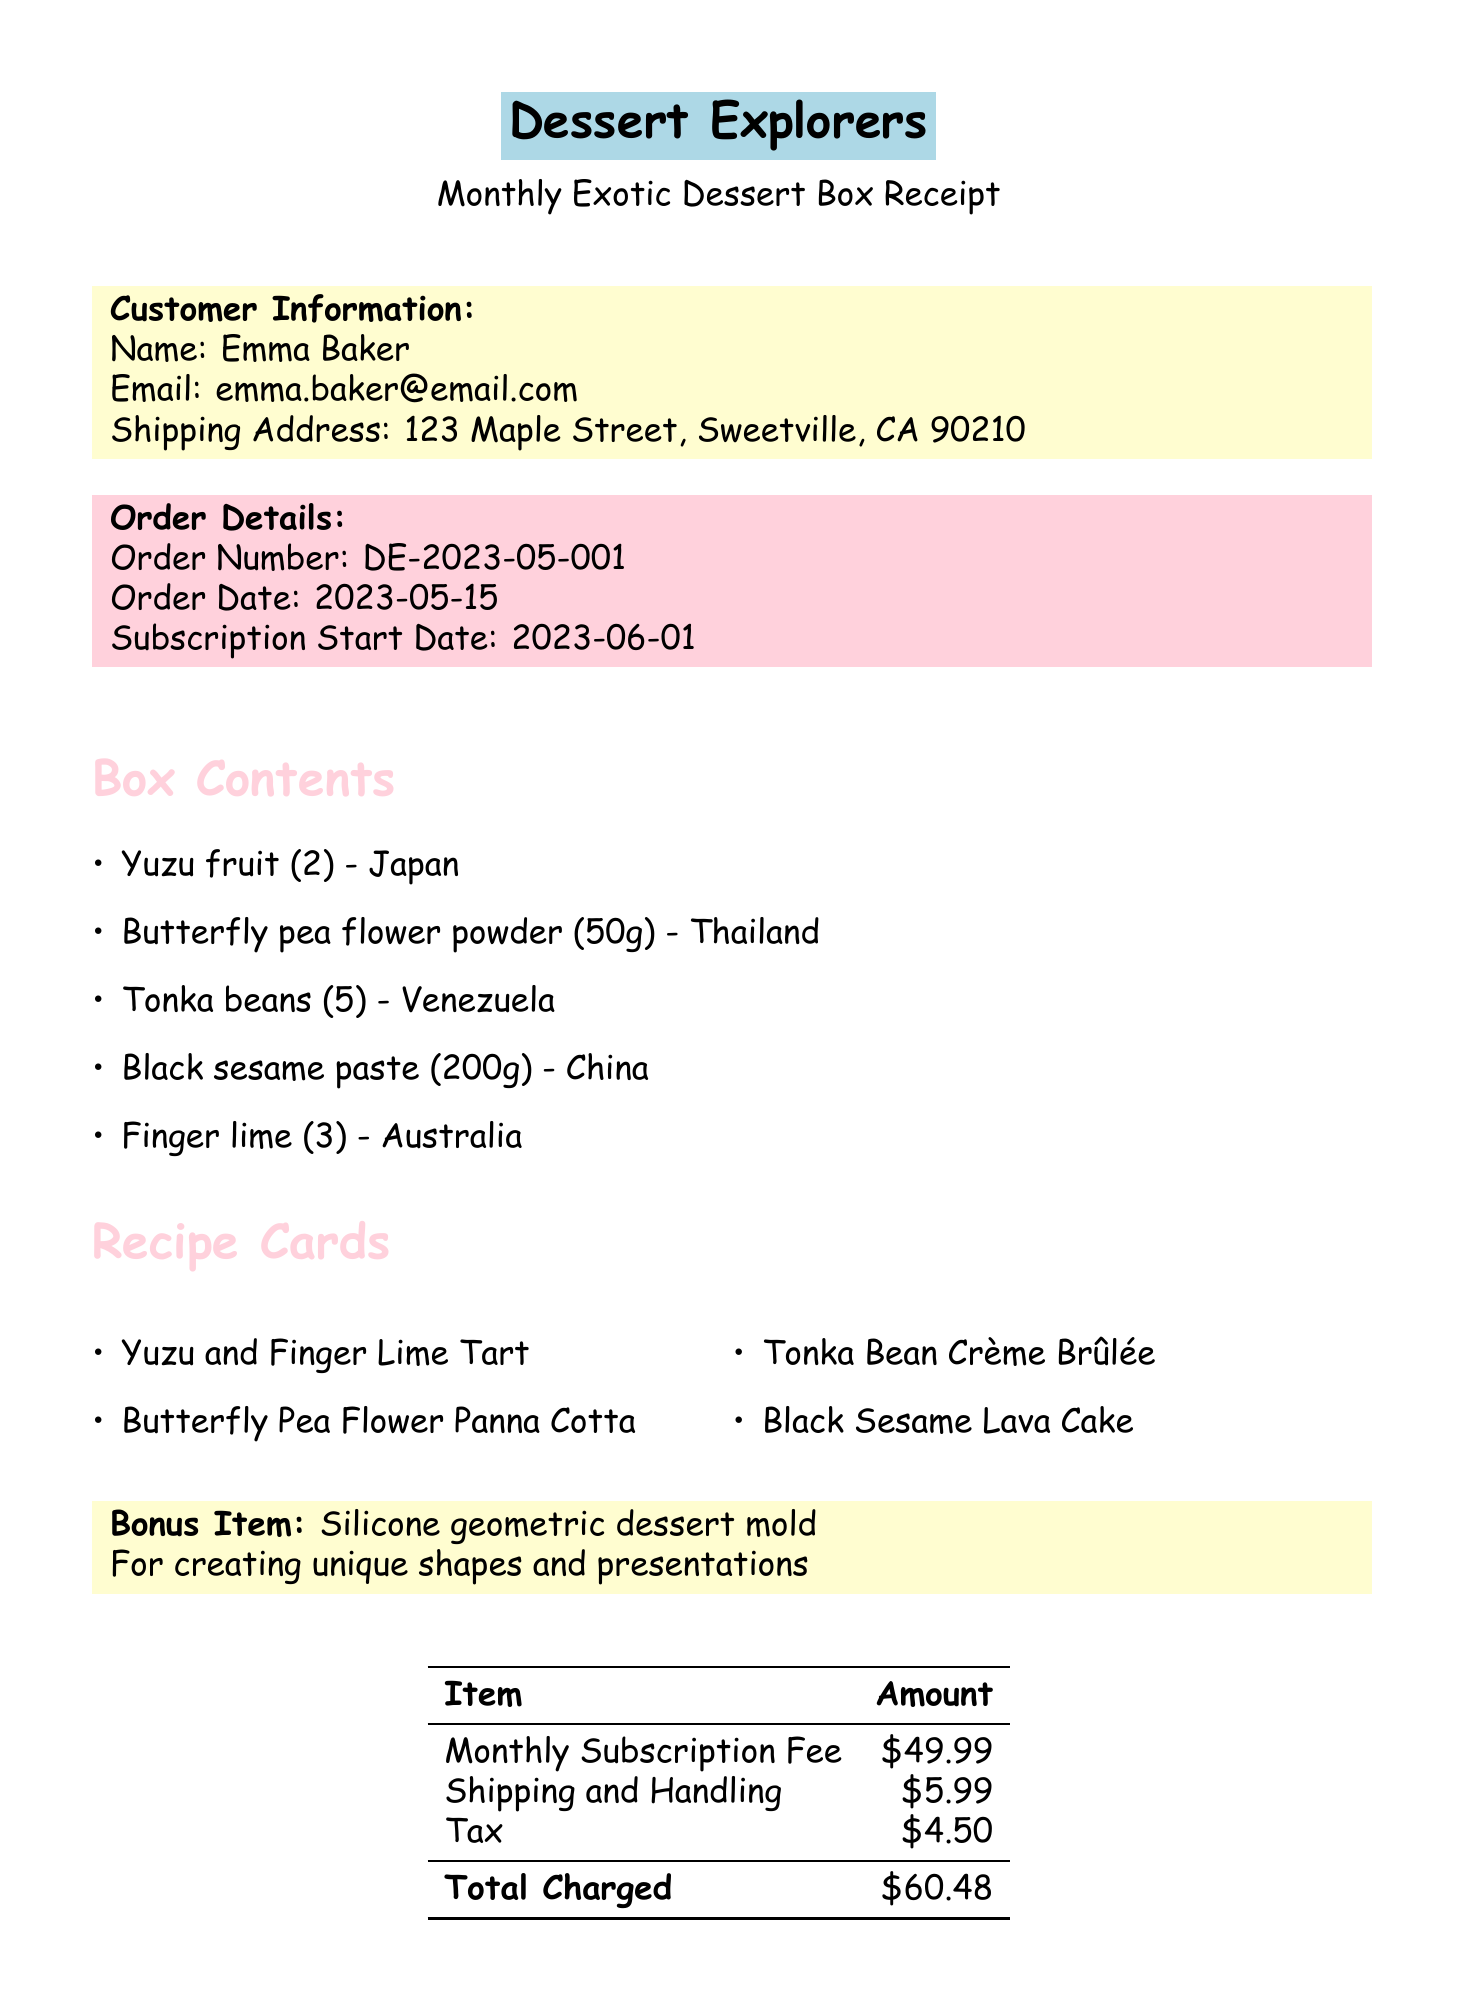What is the name of the company? The company's name is specified at the top of the document as "Dessert Explorers."
Answer: Dessert Explorers What items are included in the box? The box contents list five items along with their origins.
Answer: Yuzu fruit (2), Butterfly pea flower powder (50g), Tonka beans (5), Black sesame paste (200g), Finger lime (3) What is the total amount charged? The total charged is explicitly mentioned in the pricing section of the document.
Answer: $60.48 When does the subscription start? The subscription start date is provided in the order details section of the document.
Answer: 2023-06-01 What is the next box theme? The upcoming theme for the next box is stated in the document.
Answer: Tropical Paradise Delights Who is the customer? The name of the customer is mentioned in the customer information section.
Answer: Emma Baker Why is there a special note for novice bakers? The special note provides encouragement and resources for novice bakers to help them in their baking journey.
Answer: To provide detailed instructions and video tutorials What is the bonus item included in the box? The document specifically highlights a bonus item as part of the subscription box.
Answer: Silicone geometric dessert mold What payment method was used? The payment method is detailed at the bottom of the document.
Answer: Credit Card (ending in 1234) 